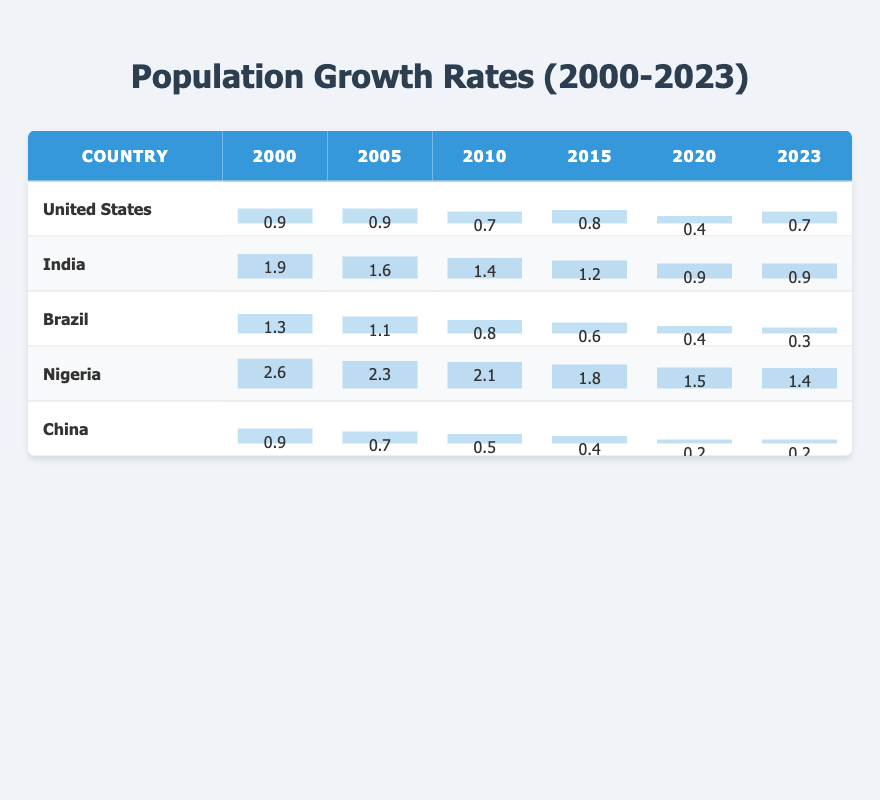What was the population growth rate of the United States in 2010? From the table, the population growth rate for the United States in 2010 is directly stated as 0.7.
Answer: 0.7 Which country had the highest population growth rate in 2000? By checking the table, Nigeria has the highest population growth rate in 2000 at 2.6.
Answer: 2.6 What is the average population growth rate of India from 2000 to 2023? To find the average, sum all the growth rates of India from 2000 (1.9) to 2023 (0.9), which totals to 24.0. There are 24 data points (2000-2023), so the average is 24.0 / 24 = 1.0.
Answer: 1.0 Did Brazil's population growth rate decrease consistently from 2010 to 2023? Looking at the table, Brazil's growth rates from 2010 (0.8), 2015 (0.6), to 2023 (0.3) show a consistent decrease: 0.8 → 0.6 → 0.3.
Answer: Yes What was the difference in population growth rates between Nigeria in 2000 and China in 2023? Nigeria had a growth rate of 2.6 in 2000 and China had 0.2 in 2023. The difference is 2.6 - 0.2 = 2.4.
Answer: 2.4 Which country had the lowest population growth rate in 2021? The table indicates that Brazil had the lowest growth rate in 2021 at 0.3.
Answer: 0.3 Is it true that India's population growth rate dropped below 1.0 after 2019? The table shows that India's rates are 1.0 in 2019, and then drop to 0.9 in 2020, confirming it dropped below 1.0 from 2020 onward.
Answer: Yes What is the trend of population growth rates for the United States from 2000 to 2023? Analyzing the data from the table, the United States shows fluctuations, generally declining first and then stabilizing around 0.6 to 0.8 from 2016 to 2023.
Answer: Fluctuating with a general decline What was the highest recorded growth rate for China from 2000 to 2023? The highest growth rate for China was 0.9 in 2000. A quick scan of the table confirms this.
Answer: 0.9 What was the population growth rate for Nigeria in 2015? Referring to the table, Nigeria's growth rate in 2015 is 1.8.
Answer: 1.8 